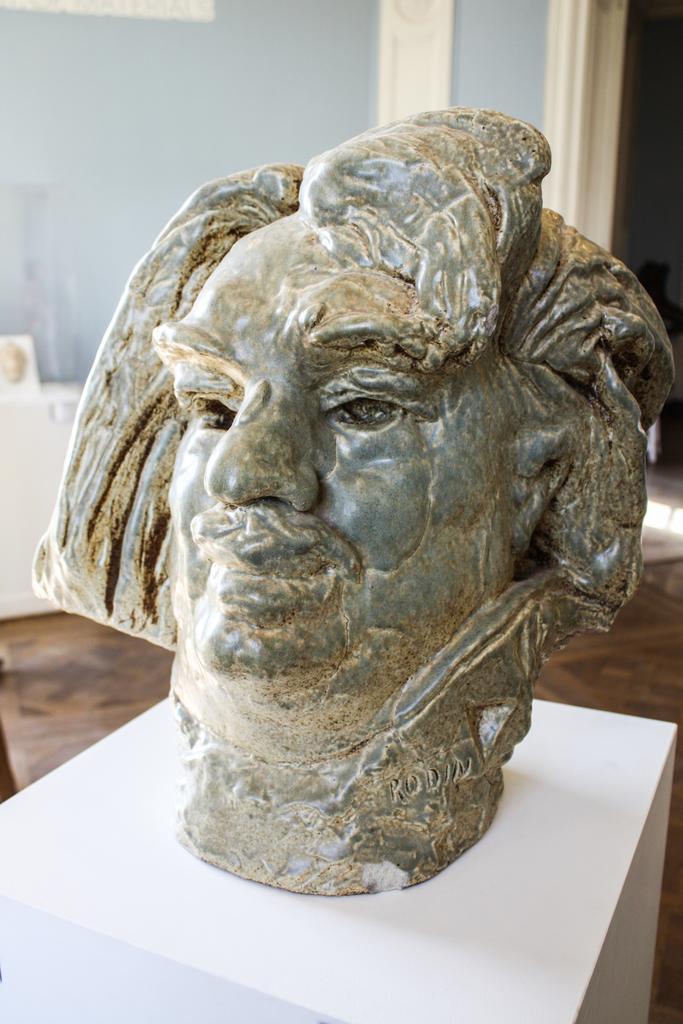Can you describe this image briefly? In this image there is a sculpture on a box, in the background there is a wall. 